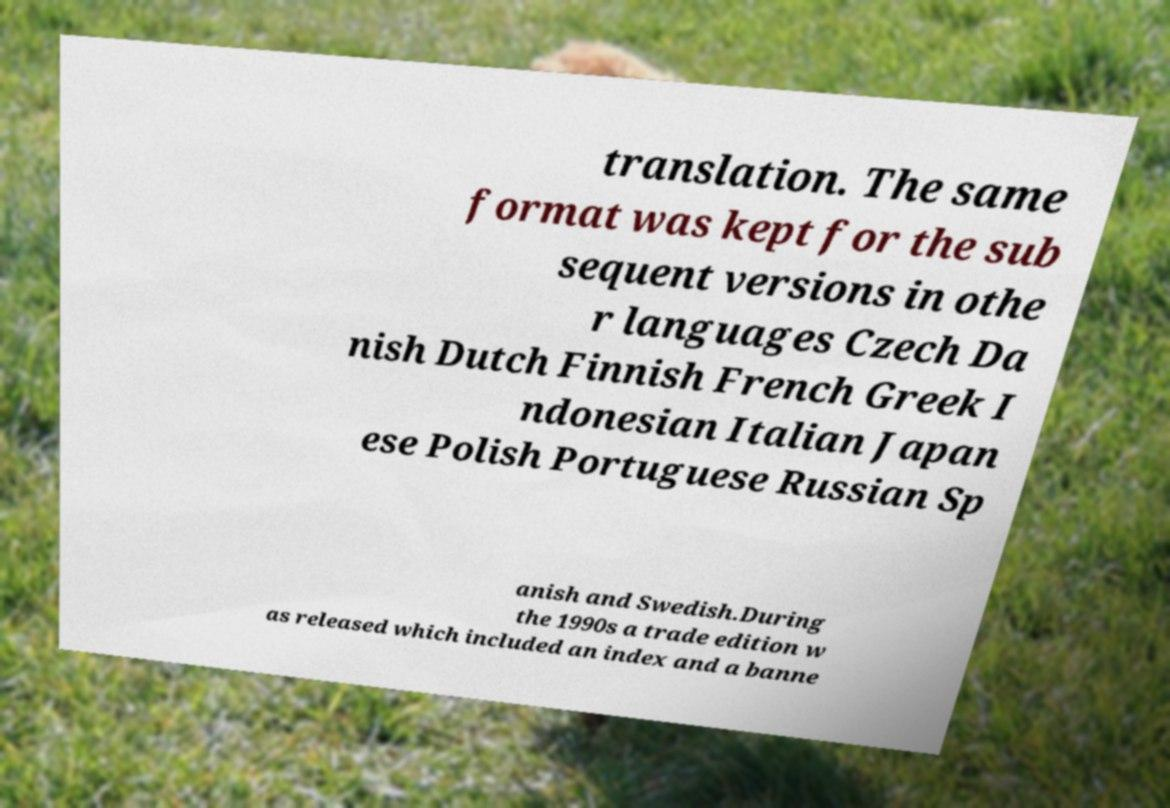Please read and relay the text visible in this image. What does it say? translation. The same format was kept for the sub sequent versions in othe r languages Czech Da nish Dutch Finnish French Greek I ndonesian Italian Japan ese Polish Portuguese Russian Sp anish and Swedish.During the 1990s a trade edition w as released which included an index and a banne 